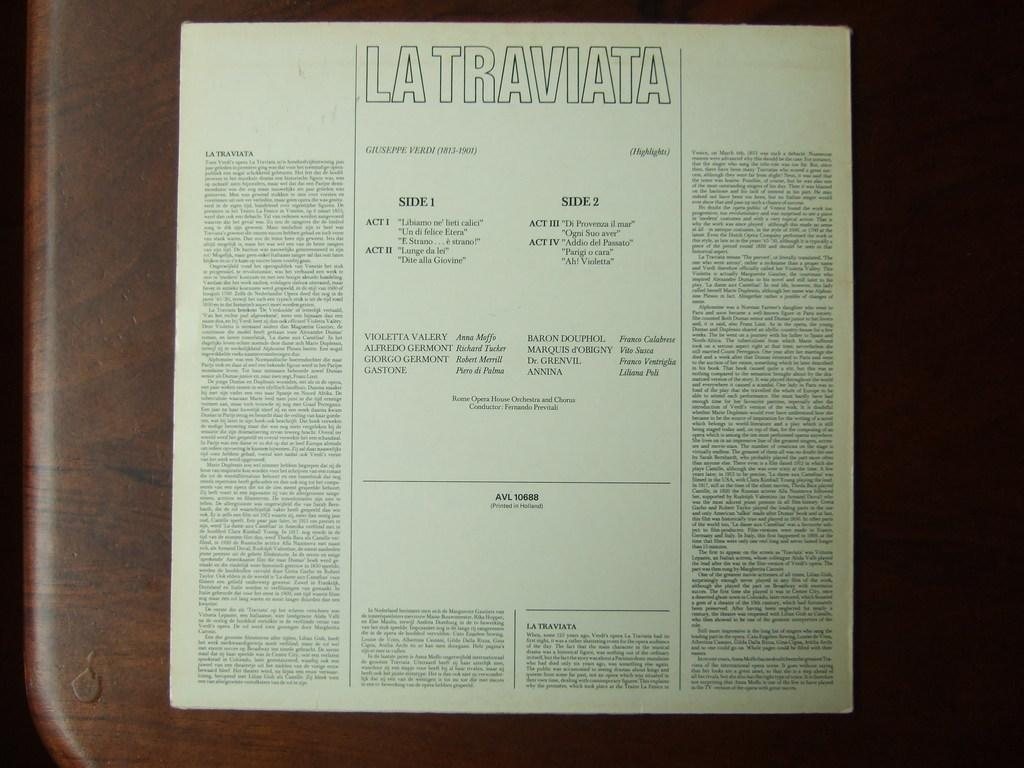Provide a one-sentence caption for the provided image. a page that says 'la traviata' at the top. 